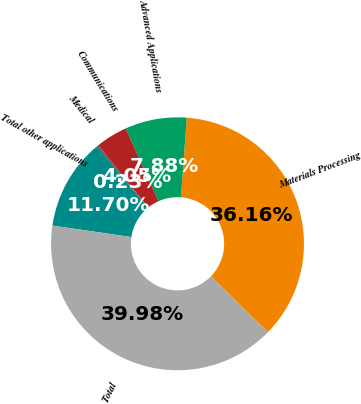Convert chart. <chart><loc_0><loc_0><loc_500><loc_500><pie_chart><fcel>Materials Processing<fcel>Advanced Applications<fcel>Communications<fcel>Medical<fcel>Total other applications<fcel>Total<nl><fcel>36.16%<fcel>7.88%<fcel>4.05%<fcel>0.23%<fcel>11.7%<fcel>39.98%<nl></chart> 